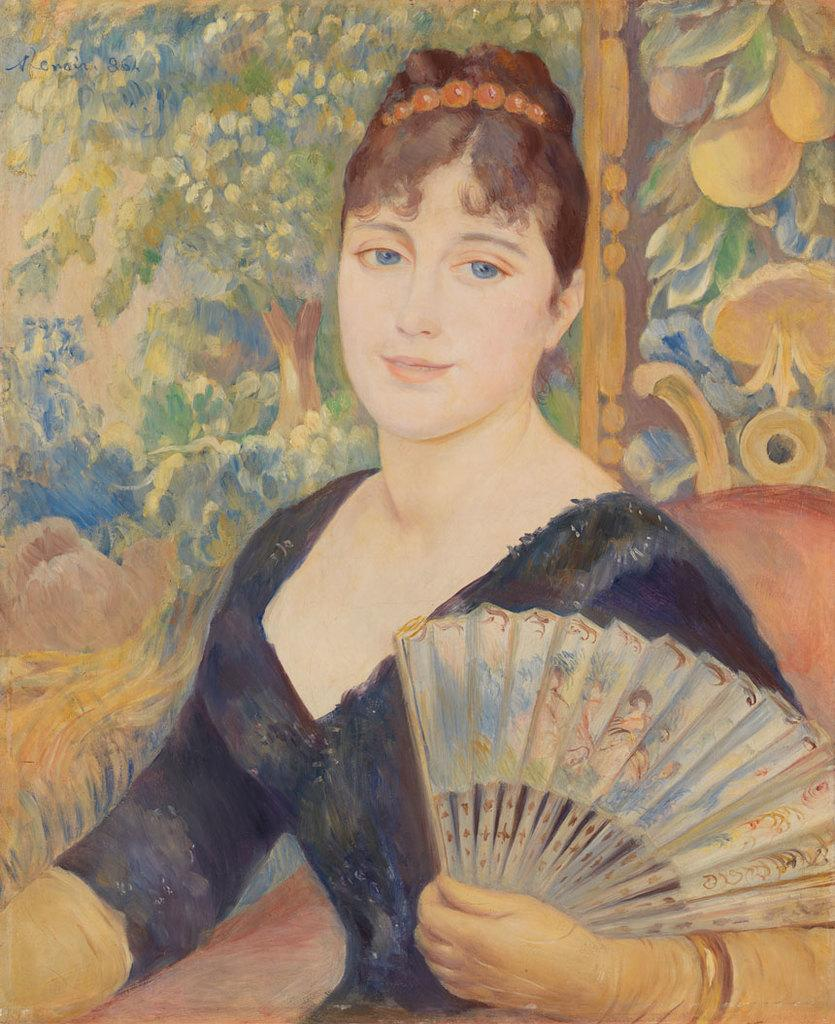What is the main subject of the image? There is a painting in the image. What does the painting depict? The painting depicts a woman. How many people are going on vacation in the image? There is no indication of anyone going on vacation in the image, as it only features a painting of a woman. What type of pen is being used to create the painting in the image? There is no pen visible in the image, as it only shows the completed painting of a woman. 